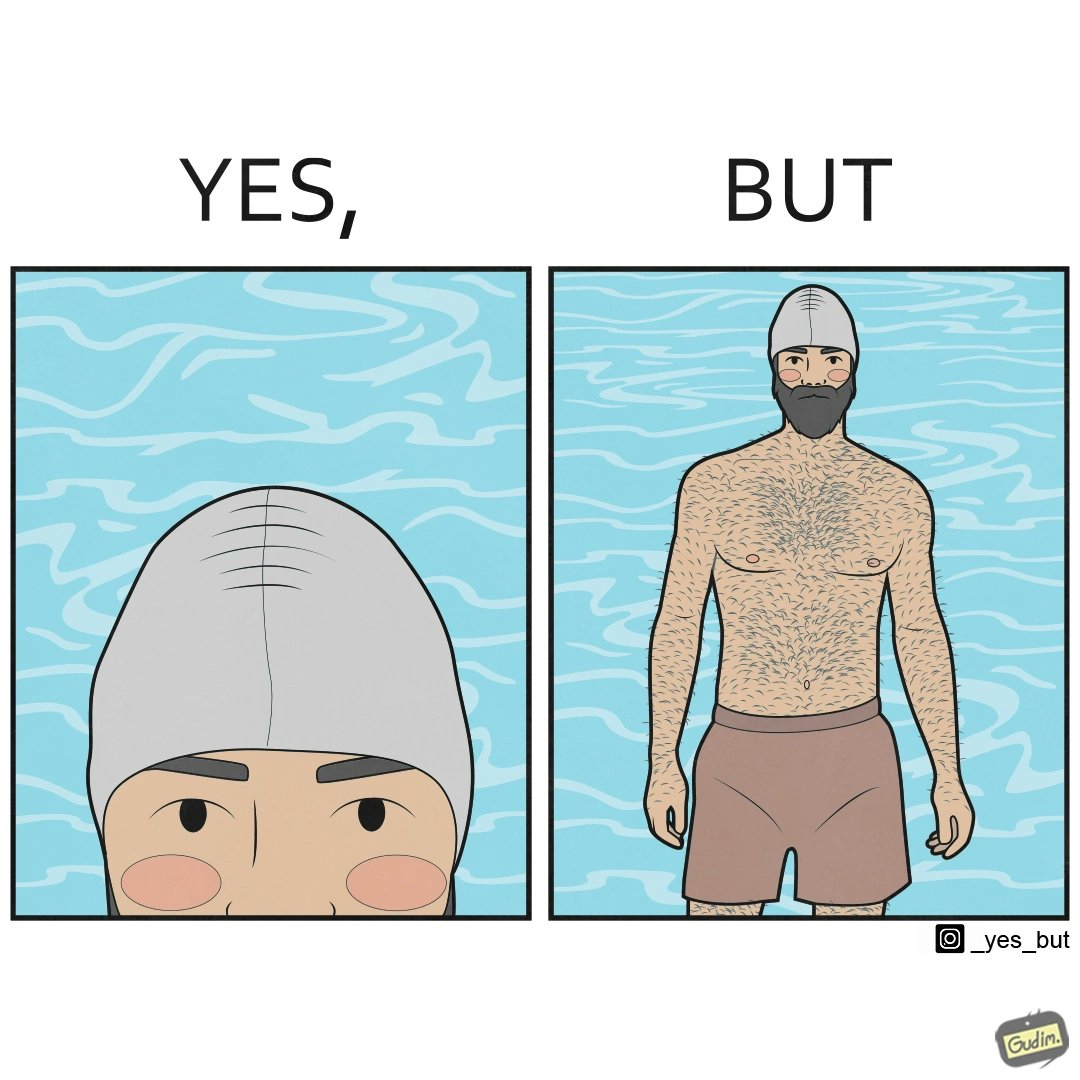What makes this image funny or satirical? The man is wearing a swimming cap to protect his head's hair but on the other side he is not concerned over the hair all over his body and is nowhere covering them 